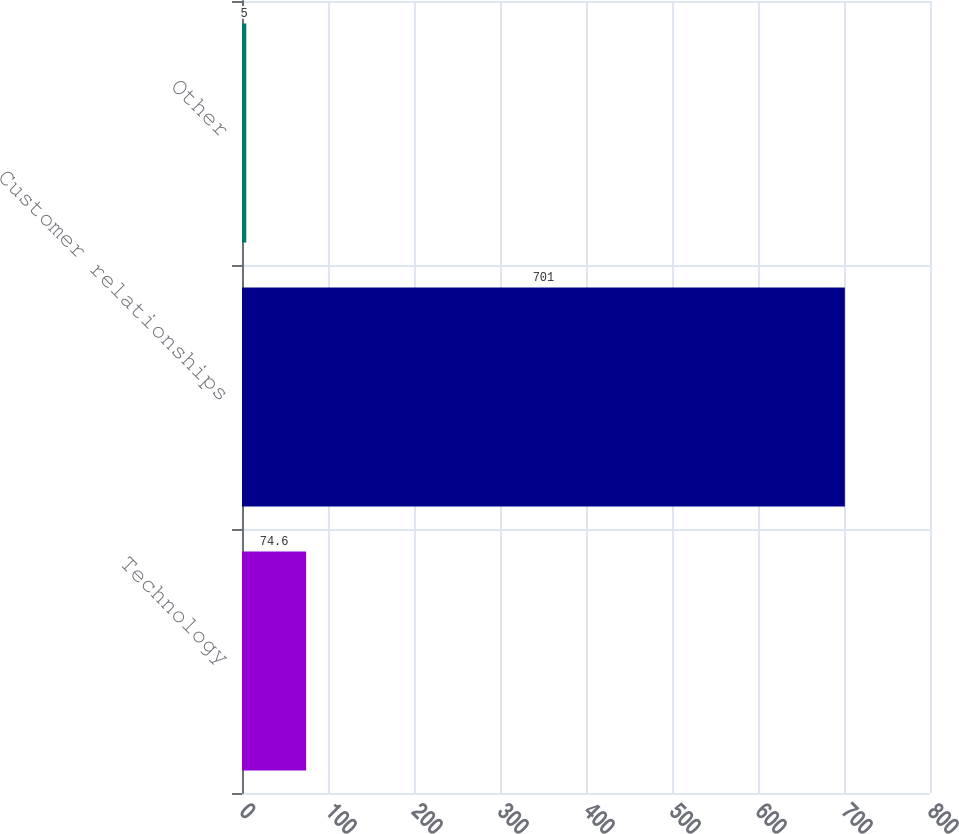Convert chart to OTSL. <chart><loc_0><loc_0><loc_500><loc_500><bar_chart><fcel>Technology<fcel>Customer relationships<fcel>Other<nl><fcel>74.6<fcel>701<fcel>5<nl></chart> 